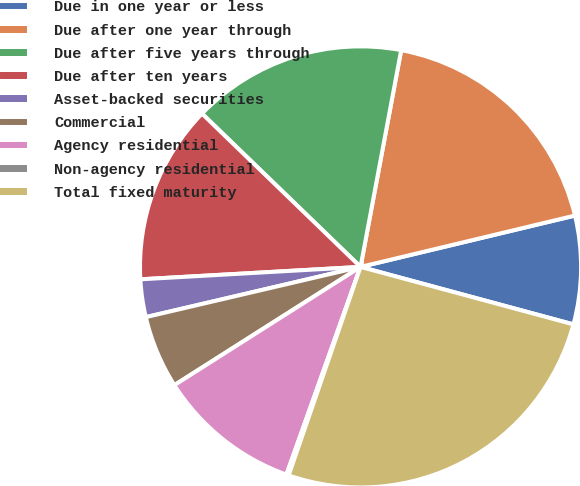<chart> <loc_0><loc_0><loc_500><loc_500><pie_chart><fcel>Due in one year or less<fcel>Due after one year through<fcel>Due after five years through<fcel>Due after ten years<fcel>Asset-backed securities<fcel>Commercial<fcel>Agency residential<fcel>Non-agency residential<fcel>Total fixed maturity<nl><fcel>7.94%<fcel>18.31%<fcel>15.72%<fcel>13.13%<fcel>2.76%<fcel>5.35%<fcel>10.54%<fcel>0.17%<fcel>26.09%<nl></chart> 